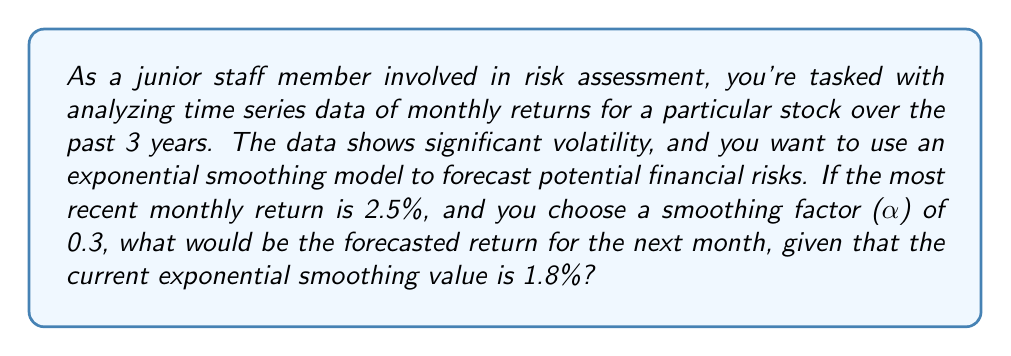Could you help me with this problem? To solve this problem, we need to use the exponential smoothing formula:

$$S_t = \alpha Y_t + (1-\alpha)S_{t-1}$$

Where:
$S_t$ is the smoothed value at time t (the forecast we're looking for)
$\alpha$ is the smoothing factor (0.3 in this case)
$Y_t$ is the most recent observation (2.5% in this case)
$S_{t-1}$ is the previous smoothed value (1.8% in this case)

Let's plug in the values:

$$S_t = 0.3 \cdot 2.5\% + (1-0.3) \cdot 1.8\%$$

Simplifying:

$$S_t = 0.3 \cdot 2.5\% + 0.7 \cdot 1.8\%$$

$$S_t = 0.75\% + 1.26\%$$

$$S_t = 2.01\%$$

This value represents the forecasted return for the next month, which helps in assessing potential financial risks. The exponential smoothing model gives more weight to recent observations while still considering historical data, making it useful for short-term forecasting in volatile markets.
Answer: The forecasted return for the next month is 2.01%. 